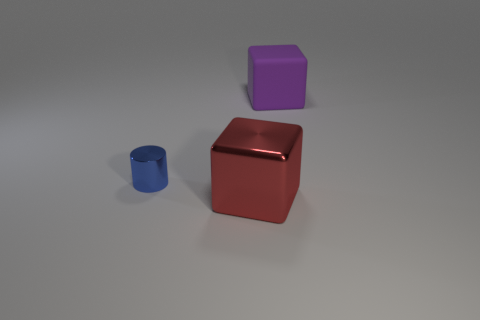Add 2 big cubes. How many objects exist? 5 Subtract all red cubes. How many cubes are left? 1 Subtract all gray cylinders. How many red cubes are left? 1 Subtract all cubes. How many objects are left? 1 Subtract 1 blocks. How many blocks are left? 1 Subtract all yellow cubes. Subtract all brown spheres. How many cubes are left? 2 Subtract all red objects. Subtract all big cubes. How many objects are left? 0 Add 2 matte things. How many matte things are left? 3 Add 3 large purple rubber cubes. How many large purple rubber cubes exist? 4 Subtract 1 blue cylinders. How many objects are left? 2 